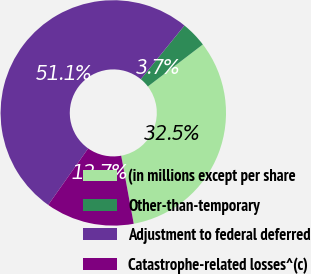<chart> <loc_0><loc_0><loc_500><loc_500><pie_chart><fcel>(in millions except per share<fcel>Other-than-temporary<fcel>Adjustment to federal deferred<fcel>Catastrophe-related losses^(c)<nl><fcel>32.48%<fcel>3.74%<fcel>51.07%<fcel>12.7%<nl></chart> 